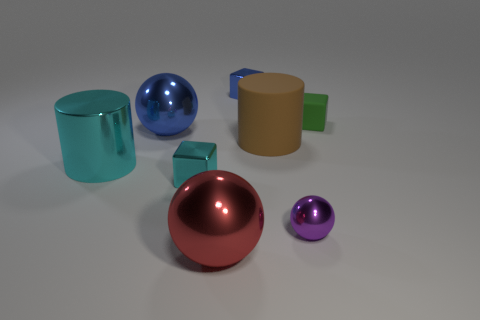Add 2 big red metal spheres. How many objects exist? 10 Subtract all cylinders. How many objects are left? 6 Subtract 1 cyan cylinders. How many objects are left? 7 Subtract all tiny yellow metallic cylinders. Subtract all brown matte things. How many objects are left? 7 Add 3 small metal spheres. How many small metal spheres are left? 4 Add 2 big blue metal balls. How many big blue metal balls exist? 3 